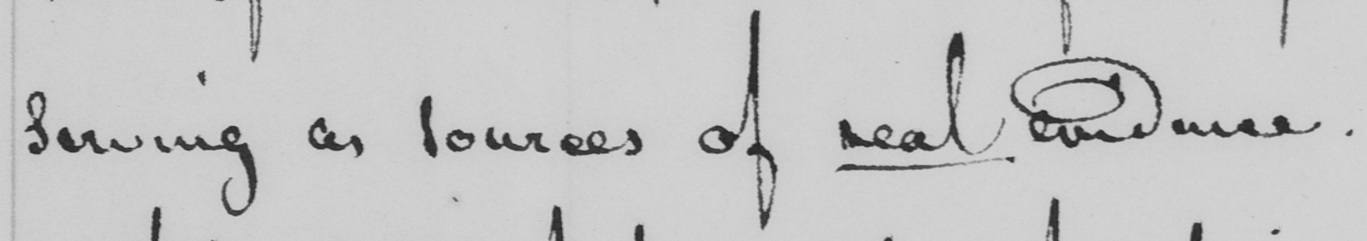Please provide the text content of this handwritten line. serving as sources of real evidence . 